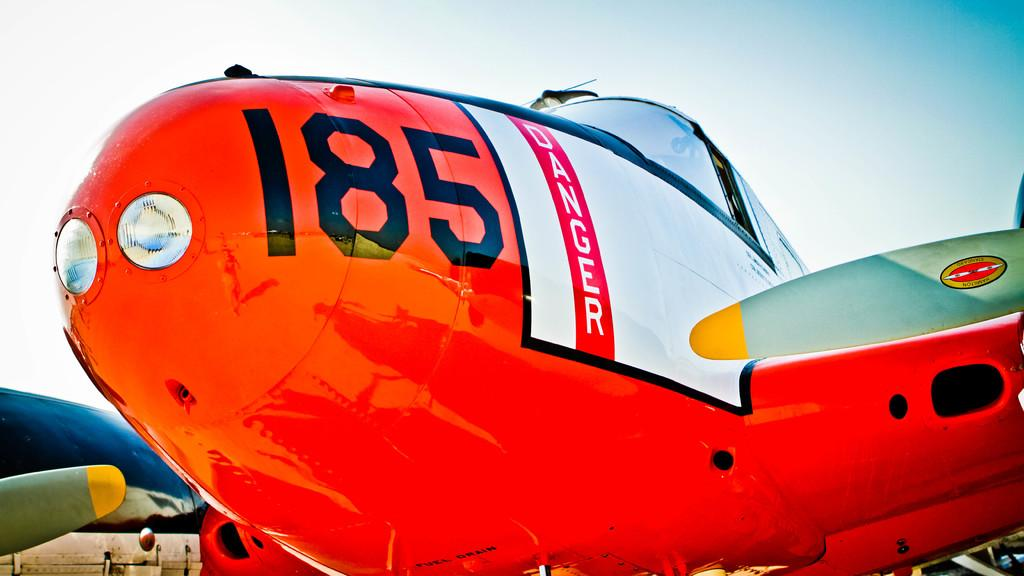What color is the airplane in the image? The airplane in the image is red. Is there any text or writing on the airplane? Yes, there is writing on the red airplane. How many airplanes can be seen in the image? There is at least one red airplane and other planes in the image. What type of sweater is the airplane wearing in the image? Airplanes do not wear sweaters, as they are inanimate objects. 